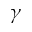<formula> <loc_0><loc_0><loc_500><loc_500>\gamma</formula> 